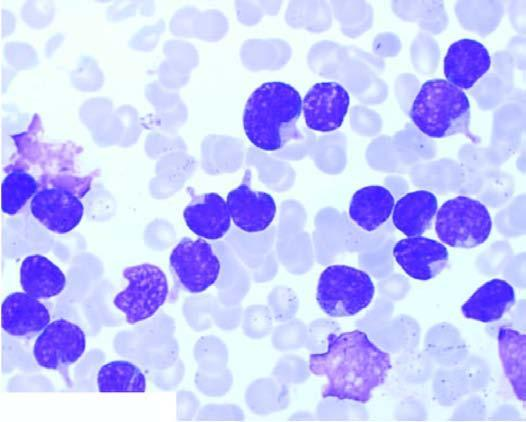re the cells large, with round to convoluted nuclei having high n/c ratio and no cytoplasmic granularity?
Answer the question using a single word or phrase. Yes 